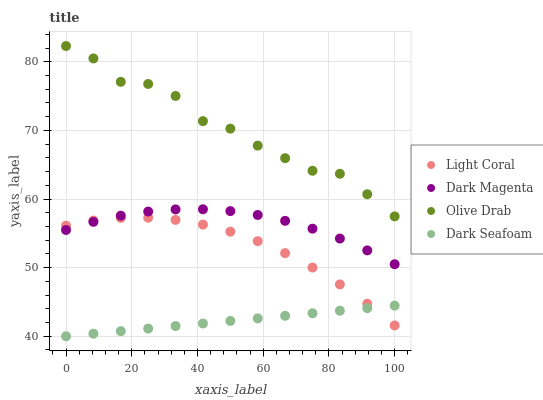Does Dark Seafoam have the minimum area under the curve?
Answer yes or no. Yes. Does Olive Drab have the maximum area under the curve?
Answer yes or no. Yes. Does Dark Magenta have the minimum area under the curve?
Answer yes or no. No. Does Dark Magenta have the maximum area under the curve?
Answer yes or no. No. Is Dark Seafoam the smoothest?
Answer yes or no. Yes. Is Olive Drab the roughest?
Answer yes or no. Yes. Is Dark Magenta the smoothest?
Answer yes or no. No. Is Dark Magenta the roughest?
Answer yes or no. No. Does Dark Seafoam have the lowest value?
Answer yes or no. Yes. Does Dark Magenta have the lowest value?
Answer yes or no. No. Does Olive Drab have the highest value?
Answer yes or no. Yes. Does Dark Magenta have the highest value?
Answer yes or no. No. Is Light Coral less than Olive Drab?
Answer yes or no. Yes. Is Olive Drab greater than Dark Magenta?
Answer yes or no. Yes. Does Light Coral intersect Dark Magenta?
Answer yes or no. Yes. Is Light Coral less than Dark Magenta?
Answer yes or no. No. Is Light Coral greater than Dark Magenta?
Answer yes or no. No. Does Light Coral intersect Olive Drab?
Answer yes or no. No. 